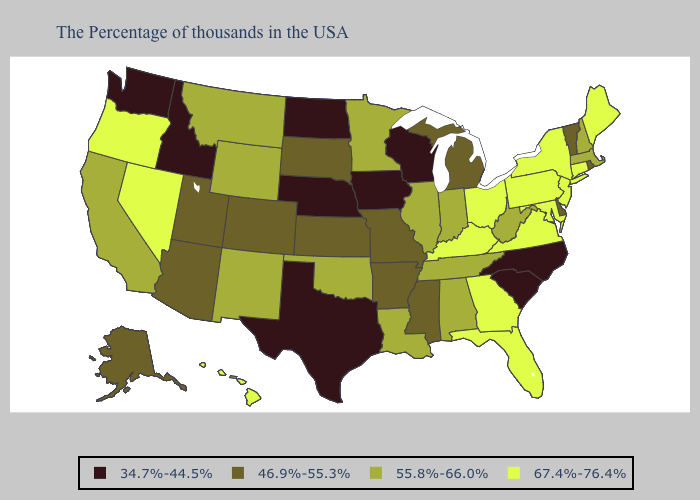What is the value of Ohio?
Give a very brief answer. 67.4%-76.4%. Name the states that have a value in the range 67.4%-76.4%?
Be succinct. Maine, Connecticut, New York, New Jersey, Maryland, Pennsylvania, Virginia, Ohio, Florida, Georgia, Kentucky, Nevada, Oregon, Hawaii. Name the states that have a value in the range 34.7%-44.5%?
Quick response, please. North Carolina, South Carolina, Wisconsin, Iowa, Nebraska, Texas, North Dakota, Idaho, Washington. Does New York have the highest value in the Northeast?
Quick response, please. Yes. Does Washington have the lowest value in the West?
Quick response, please. Yes. How many symbols are there in the legend?
Answer briefly. 4. Does Mississippi have the same value as New Hampshire?
Be succinct. No. Which states have the highest value in the USA?
Short answer required. Maine, Connecticut, New York, New Jersey, Maryland, Pennsylvania, Virginia, Ohio, Florida, Georgia, Kentucky, Nevada, Oregon, Hawaii. What is the value of North Dakota?
Quick response, please. 34.7%-44.5%. What is the highest value in states that border Texas?
Quick response, please. 55.8%-66.0%. What is the highest value in the South ?
Quick response, please. 67.4%-76.4%. Does New Jersey have the lowest value in the USA?
Answer briefly. No. How many symbols are there in the legend?
Quick response, please. 4. What is the lowest value in the USA?
Write a very short answer. 34.7%-44.5%. What is the value of Illinois?
Give a very brief answer. 55.8%-66.0%. 